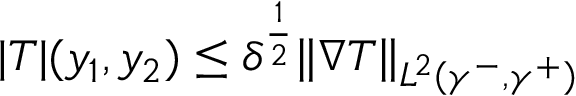Convert formula to latex. <formula><loc_0><loc_0><loc_500><loc_500>\begin{array} { r } { | T | ( y _ { 1 } , y _ { 2 } ) \leq \delta ^ { \frac { 1 } { 2 } } \| \nabla T \| _ { L ^ { 2 } ( \gamma ^ { - } , \gamma ^ { + } ) } } \end{array}</formula> 